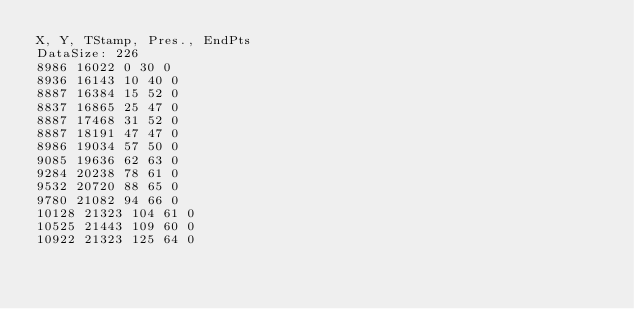Convert code to text. <code><loc_0><loc_0><loc_500><loc_500><_SML_>X, Y, TStamp, Pres., EndPts
DataSize: 226
8986 16022 0 30 0
8936 16143 10 40 0
8887 16384 15 52 0
8837 16865 25 47 0
8887 17468 31 52 0
8887 18191 47 47 0
8986 19034 57 50 0
9085 19636 62 63 0
9284 20238 78 61 0
9532 20720 88 65 0
9780 21082 94 66 0
10128 21323 104 61 0
10525 21443 109 60 0
10922 21323 125 64 0</code> 